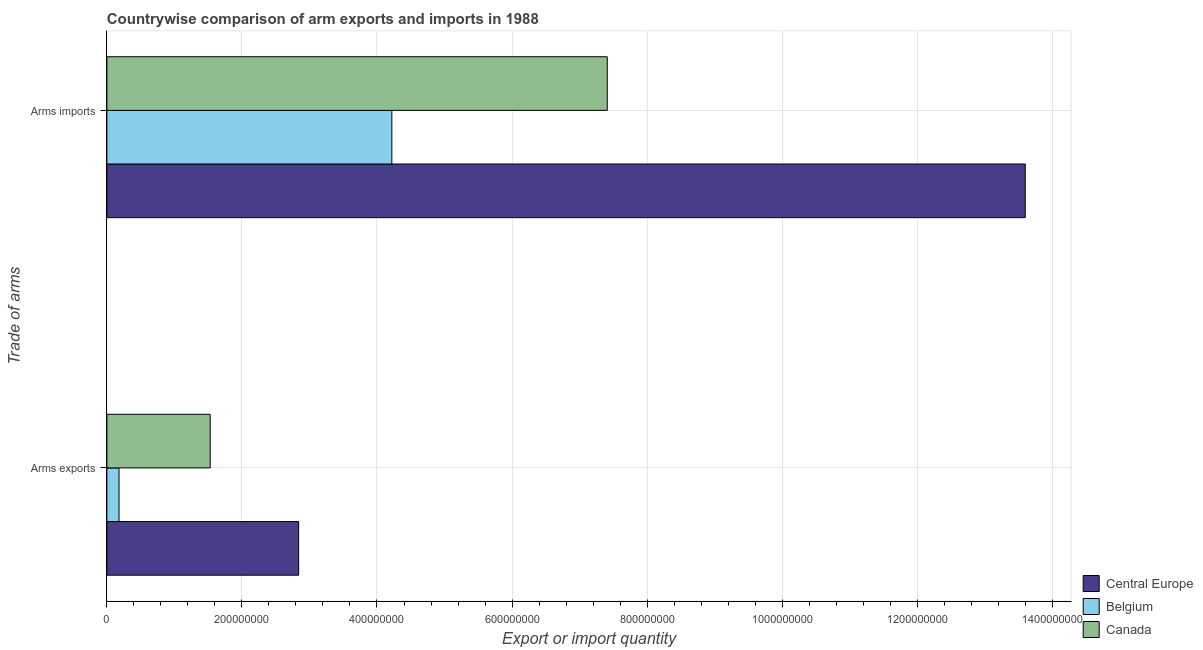How many different coloured bars are there?
Your response must be concise. 3. How many groups of bars are there?
Give a very brief answer. 2. Are the number of bars per tick equal to the number of legend labels?
Make the answer very short. Yes. Are the number of bars on each tick of the Y-axis equal?
Provide a succinct answer. Yes. How many bars are there on the 2nd tick from the top?
Provide a short and direct response. 3. How many bars are there on the 1st tick from the bottom?
Your answer should be very brief. 3. What is the label of the 1st group of bars from the top?
Provide a short and direct response. Arms imports. What is the arms imports in Canada?
Provide a short and direct response. 7.41e+08. Across all countries, what is the maximum arms imports?
Your response must be concise. 1.36e+09. Across all countries, what is the minimum arms exports?
Ensure brevity in your answer.  1.80e+07. In which country was the arms imports maximum?
Your answer should be very brief. Central Europe. In which country was the arms imports minimum?
Make the answer very short. Belgium. What is the total arms exports in the graph?
Ensure brevity in your answer.  4.55e+08. What is the difference between the arms imports in Belgium and that in Central Europe?
Your answer should be very brief. -9.38e+08. What is the difference between the arms exports in Central Europe and the arms imports in Canada?
Provide a short and direct response. -4.57e+08. What is the average arms exports per country?
Your answer should be compact. 1.52e+08. What is the difference between the arms imports and arms exports in Canada?
Give a very brief answer. 5.88e+08. In how many countries, is the arms exports greater than 1040000000 ?
Ensure brevity in your answer.  0. What is the ratio of the arms imports in Belgium to that in Canada?
Offer a terse response. 0.57. In how many countries, is the arms imports greater than the average arms imports taken over all countries?
Your answer should be compact. 1. What does the 1st bar from the bottom in Arms imports represents?
Provide a short and direct response. Central Europe. Are all the bars in the graph horizontal?
Make the answer very short. Yes. What is the difference between two consecutive major ticks on the X-axis?
Your answer should be very brief. 2.00e+08. Does the graph contain grids?
Ensure brevity in your answer.  Yes. Where does the legend appear in the graph?
Keep it short and to the point. Bottom right. How many legend labels are there?
Offer a terse response. 3. How are the legend labels stacked?
Offer a terse response. Vertical. What is the title of the graph?
Your answer should be very brief. Countrywise comparison of arm exports and imports in 1988. What is the label or title of the X-axis?
Make the answer very short. Export or import quantity. What is the label or title of the Y-axis?
Your response must be concise. Trade of arms. What is the Export or import quantity of Central Europe in Arms exports?
Give a very brief answer. 2.84e+08. What is the Export or import quantity in Belgium in Arms exports?
Give a very brief answer. 1.80e+07. What is the Export or import quantity in Canada in Arms exports?
Offer a terse response. 1.53e+08. What is the Export or import quantity of Central Europe in Arms imports?
Make the answer very short. 1.36e+09. What is the Export or import quantity in Belgium in Arms imports?
Your answer should be compact. 4.22e+08. What is the Export or import quantity of Canada in Arms imports?
Your answer should be compact. 7.41e+08. Across all Trade of arms, what is the maximum Export or import quantity of Central Europe?
Your answer should be very brief. 1.36e+09. Across all Trade of arms, what is the maximum Export or import quantity in Belgium?
Provide a short and direct response. 4.22e+08. Across all Trade of arms, what is the maximum Export or import quantity in Canada?
Offer a terse response. 7.41e+08. Across all Trade of arms, what is the minimum Export or import quantity in Central Europe?
Your answer should be compact. 2.84e+08. Across all Trade of arms, what is the minimum Export or import quantity of Belgium?
Provide a short and direct response. 1.80e+07. Across all Trade of arms, what is the minimum Export or import quantity in Canada?
Ensure brevity in your answer.  1.53e+08. What is the total Export or import quantity in Central Europe in the graph?
Your response must be concise. 1.64e+09. What is the total Export or import quantity of Belgium in the graph?
Offer a very short reply. 4.40e+08. What is the total Export or import quantity in Canada in the graph?
Provide a short and direct response. 8.94e+08. What is the difference between the Export or import quantity in Central Europe in Arms exports and that in Arms imports?
Ensure brevity in your answer.  -1.08e+09. What is the difference between the Export or import quantity in Belgium in Arms exports and that in Arms imports?
Make the answer very short. -4.04e+08. What is the difference between the Export or import quantity in Canada in Arms exports and that in Arms imports?
Your response must be concise. -5.88e+08. What is the difference between the Export or import quantity in Central Europe in Arms exports and the Export or import quantity in Belgium in Arms imports?
Provide a short and direct response. -1.38e+08. What is the difference between the Export or import quantity in Central Europe in Arms exports and the Export or import quantity in Canada in Arms imports?
Keep it short and to the point. -4.57e+08. What is the difference between the Export or import quantity of Belgium in Arms exports and the Export or import quantity of Canada in Arms imports?
Make the answer very short. -7.23e+08. What is the average Export or import quantity in Central Europe per Trade of arms?
Offer a very short reply. 8.22e+08. What is the average Export or import quantity in Belgium per Trade of arms?
Give a very brief answer. 2.20e+08. What is the average Export or import quantity in Canada per Trade of arms?
Your response must be concise. 4.47e+08. What is the difference between the Export or import quantity in Central Europe and Export or import quantity in Belgium in Arms exports?
Provide a succinct answer. 2.66e+08. What is the difference between the Export or import quantity of Central Europe and Export or import quantity of Canada in Arms exports?
Provide a succinct answer. 1.31e+08. What is the difference between the Export or import quantity in Belgium and Export or import quantity in Canada in Arms exports?
Your answer should be very brief. -1.35e+08. What is the difference between the Export or import quantity of Central Europe and Export or import quantity of Belgium in Arms imports?
Provide a short and direct response. 9.38e+08. What is the difference between the Export or import quantity in Central Europe and Export or import quantity in Canada in Arms imports?
Keep it short and to the point. 6.19e+08. What is the difference between the Export or import quantity of Belgium and Export or import quantity of Canada in Arms imports?
Offer a terse response. -3.19e+08. What is the ratio of the Export or import quantity of Central Europe in Arms exports to that in Arms imports?
Provide a short and direct response. 0.21. What is the ratio of the Export or import quantity of Belgium in Arms exports to that in Arms imports?
Keep it short and to the point. 0.04. What is the ratio of the Export or import quantity in Canada in Arms exports to that in Arms imports?
Make the answer very short. 0.21. What is the difference between the highest and the second highest Export or import quantity in Central Europe?
Provide a succinct answer. 1.08e+09. What is the difference between the highest and the second highest Export or import quantity in Belgium?
Provide a succinct answer. 4.04e+08. What is the difference between the highest and the second highest Export or import quantity in Canada?
Offer a very short reply. 5.88e+08. What is the difference between the highest and the lowest Export or import quantity of Central Europe?
Give a very brief answer. 1.08e+09. What is the difference between the highest and the lowest Export or import quantity in Belgium?
Offer a terse response. 4.04e+08. What is the difference between the highest and the lowest Export or import quantity in Canada?
Your answer should be compact. 5.88e+08. 